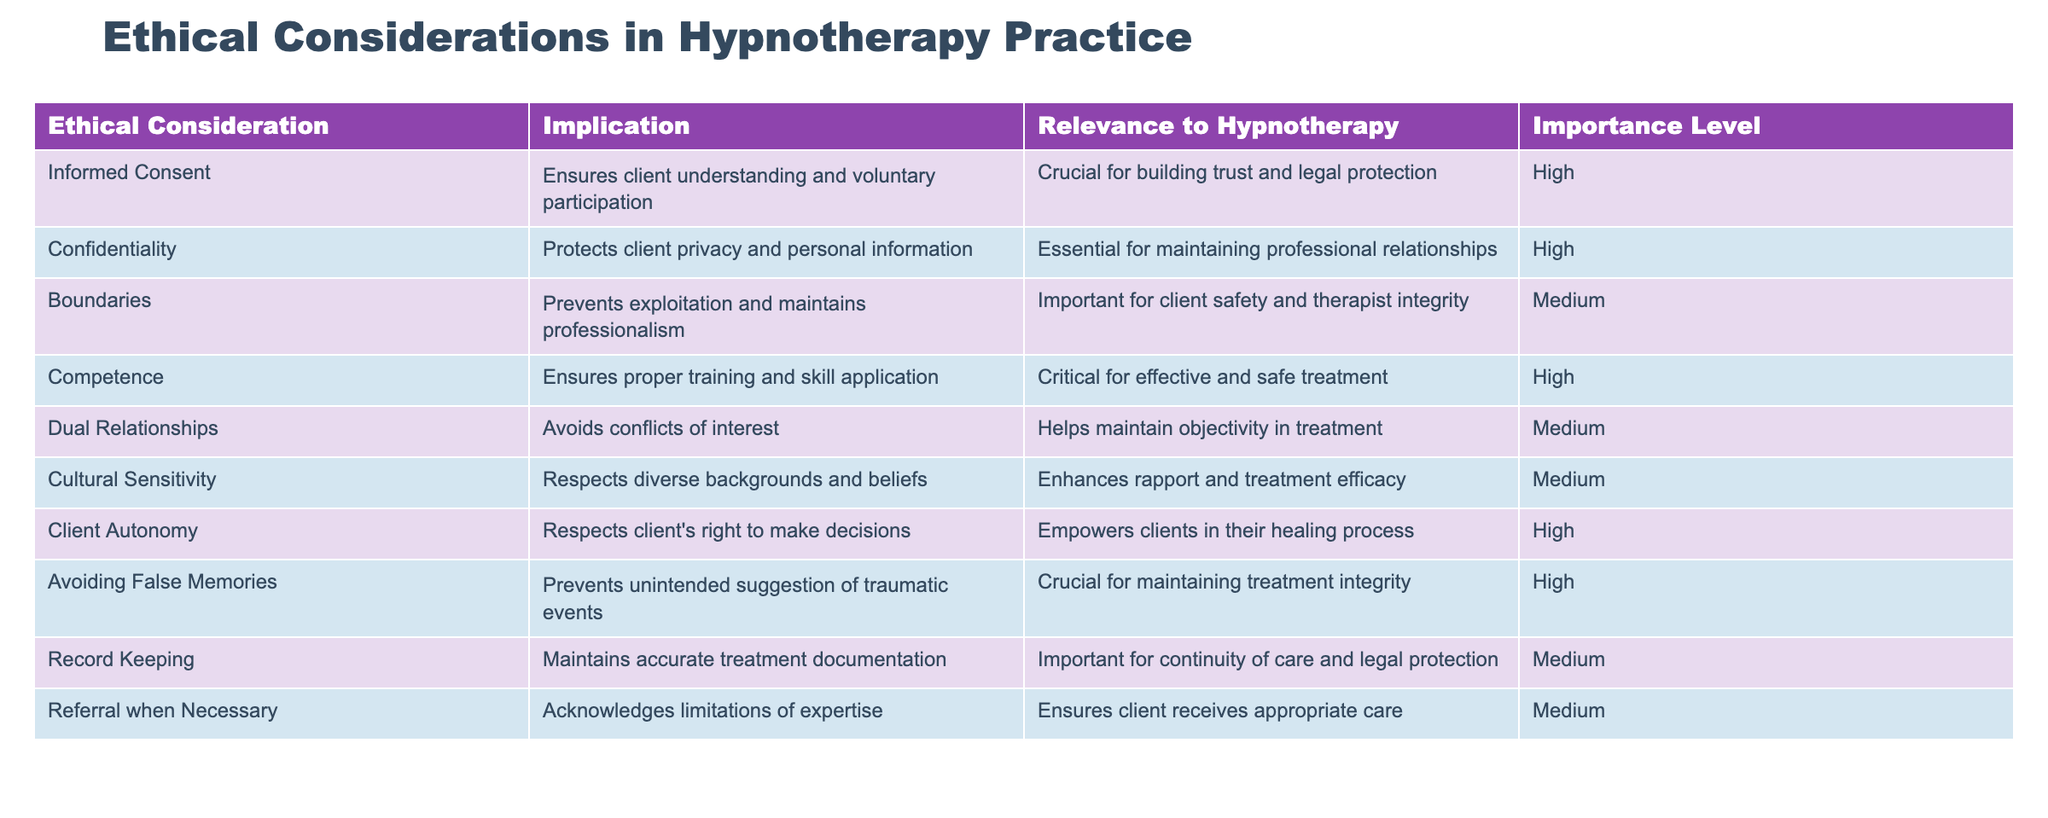What is the ethical consideration with the highest importance level? By examining the "Importance Level" column, I see that "Informed Consent," "Confidentiality," "Competence," "Client Autonomy," and "Avoiding False Memories" are all marked as high importance. Among these, "Informed Consent" is the first entry listed, making it the one with the highest importance according to the order in the table.
Answer: Informed Consent How many ethical considerations are listed as having medium importance? The table shows a total of 11 entries. By counting the rows where the importance level is marked as medium, I find that "Boundaries," "Dual Relationships," "Cultural Sensitivity," "Record Keeping," and "Referral when Necessary" all have medium importance. In total, there are 5 such ethical considerations.
Answer: 5 Is confidentiality critical for maintaining professional relationships? The table states that confidentiality is essential for maintaining professional relationships, indicating that it is more than critical. Therefore, the answer to whether confidentiality is critical is true.
Answer: Yes Which ethical consideration aims to prevent unintended suggestion of traumatic events? I look at the "Implication" column and find that "Avoiding False Memories" is the consideration that specifically states it prevents unintended suggestion of traumatic events, thus addressing this concern directly.
Answer: Avoiding False Memories If a therapist adheres to ethical boundaries, can they also maintain professionalism? The table indicates that boundaries prevent exploitation and maintain professionalism. Therefore, adherence to ethical boundaries directly contributes to maintaining professionalism.
Answer: Yes What ethical consideration is most relevant for building trust and legal protection? According to the table, "Informed Consent" is marked as crucial for building trust and legal protection, making it the main ethical consideration for this purpose.
Answer: Informed Consent What are two ethical considerations identified as having high importance? The high importance ethical considerations listed in the table include "Informed Consent" and "Competence." These two considerations are highlighted as crucial for ethical practice in hypnotherapy.
Answer: Informed Consent, Competence How can cultural sensitivity enhance treatment efficacy? The "Implication" for cultural sensitivity in the table suggests that it enhances rapport and treatment efficacy by respecting diverse backgrounds and beliefs. This explains how cultural sensitivity directly contributes to better outcomes in therapy.
Answer: It enhances rapport and treatment efficacy How many ethical considerations emphasize client autonomy? In the table, "Client Autonomy" is specifically noted for respecting the client's right to make decisions and empowering them in their healing process. It is the only entry emphasizing client autonomy.
Answer: 1 